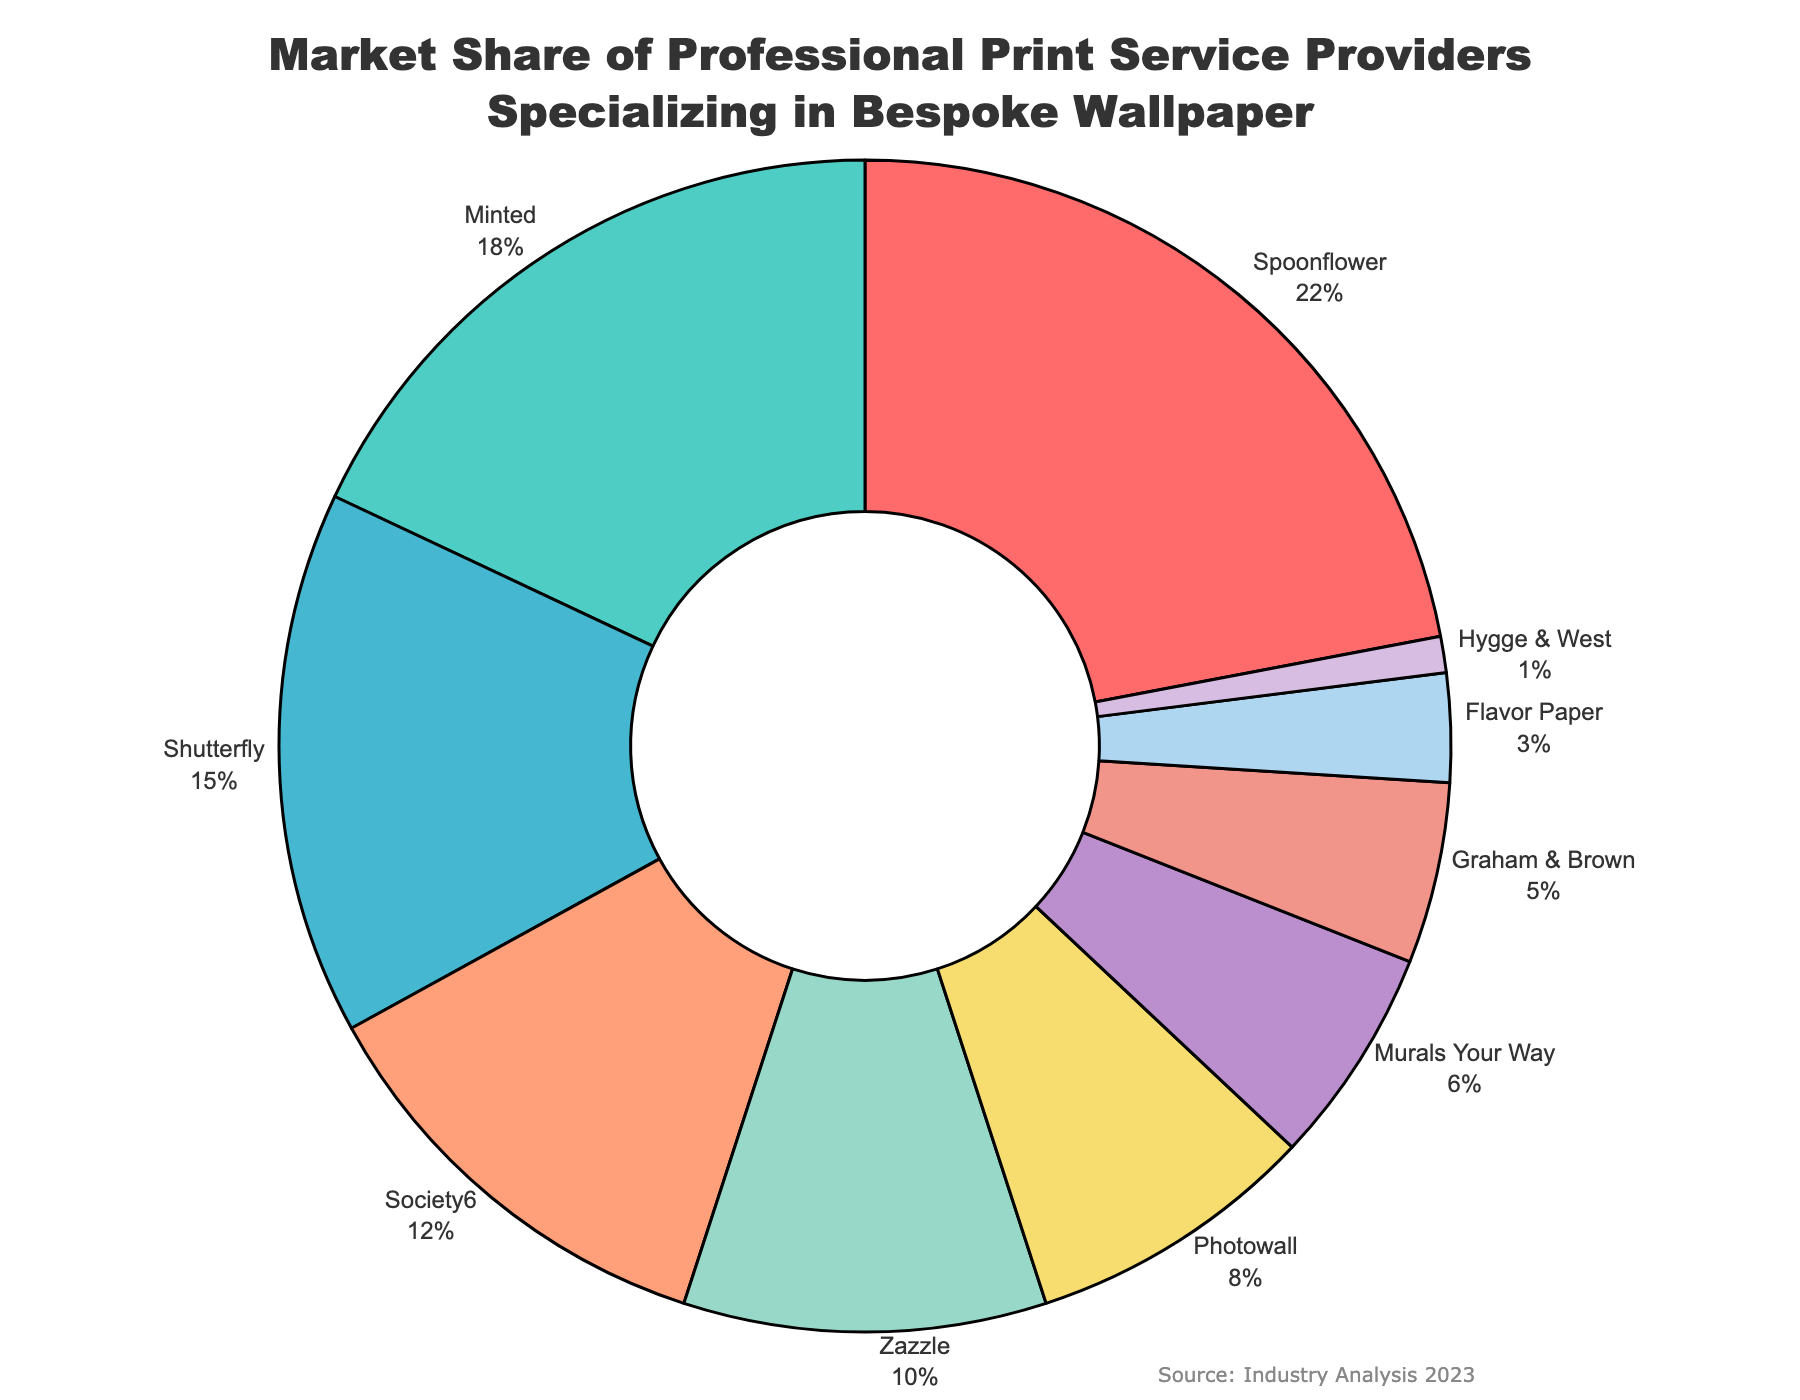What is the market share of Spoonflower? Spoonflower has the largest segment of the pie chart. It occupies a visibly larger portion compared to others and its market share is shown in the figure as 22%.
Answer: 22% Which company has the smallest market share? In the pie chart, the smallest slice corresponds to Hygge & West, indicating it has the smallest market share among the listed companies.
Answer: Hygge & West How much more market share does Spoonflower have compared to Minted? Spoonflower has 22% and Minted has 18%. The difference in their market share is 22% - 18% = 4%.
Answer: 4% What is the combined market share of Society6 and Zazzle? Society6's market share is 12% and Zazzle's is 10%. Their combined market share is 12% + 10% = 22%.
Answer: 22% What is the total market share of companies with a share less than 10%? Companies with a market share less than 10% are Photowall (8%), Murals Your Way (6%), Graham & Brown (5%), Flavor Paper (3%), and Hygge & West (1%). Summing these gives 8% + 6% + 5% + 3% + 1% = 23%.
Answer: 23% Which company has a market share closest to that of Shutterfly? Shutterfly has a market share of 15%. Society6 has a market share of 12% which is the closest to 15%.
Answer: Society6 How does the combined market share of Photowall and Murals Your Way compare to that of Shutterfly? Photowall has 8% and Murals Your Way has 6%, which sums to 8% + 6% = 14%. Shutterfly has 15%. Thus, the combined share of Photowall and Murals Your Way is smaller than Shutterfly's share by 1%.
Answer: Smaller by 1% Which companies have a market share between 10% and 20%? By examining the pie chart, Minted (18%), Shutterfly (15%), Society6 (12%), and Zazzle (10%) all fall in the range between 10% and 20%.
Answer: Minted, Shutterfly, Society6, Zazzle What percentage of the market share do the top three companies collectively hold? The top three companies in terms of market share are Spoonflower (22%), Minted (18%), and Shutterfly (15%). The total market share is 22% + 18% + 15% = 55%.
Answer: 55% Which company's market share is displayed in a blue segment of the pie chart? The company whose market share segment is colored blue is identified as Shutterfly.
Answer: Shutterfly 